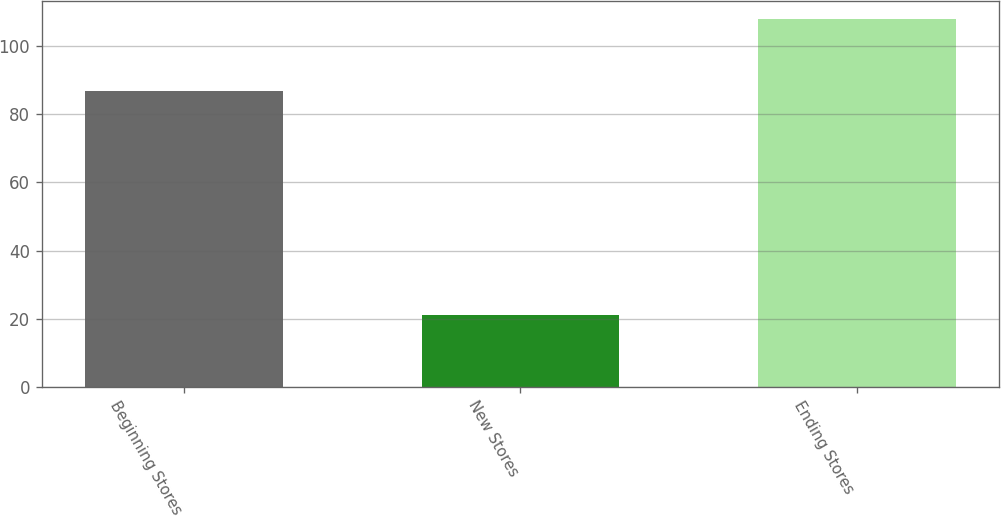<chart> <loc_0><loc_0><loc_500><loc_500><bar_chart><fcel>Beginning Stores<fcel>New Stores<fcel>Ending Stores<nl><fcel>87<fcel>21<fcel>108<nl></chart> 